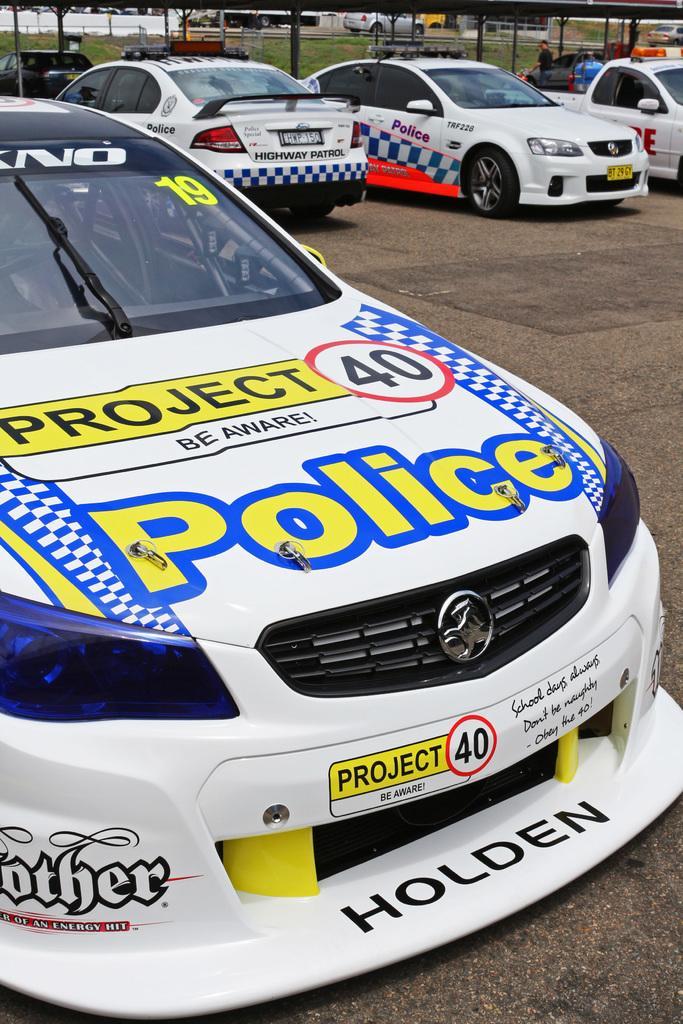How would you summarize this image in a sentence or two? In this picture there are cars in the foreground. At the back there is a shed and there is a person and their might be a building. At the bottom there is a road and there is grass. 